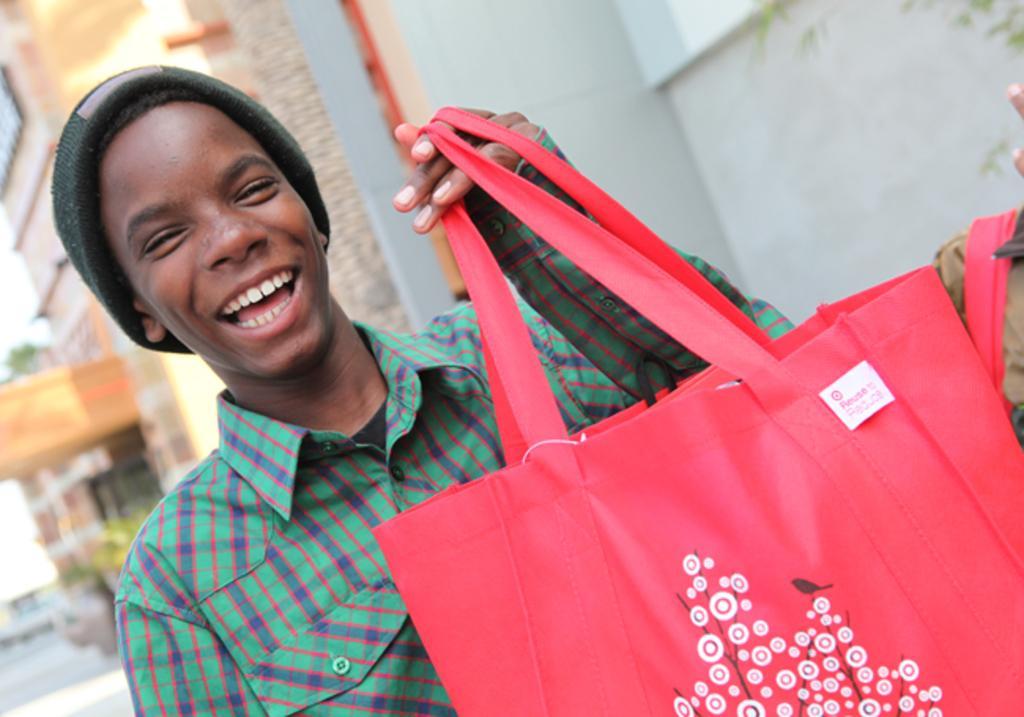Can you describe this image briefly? There is a man with a green shirt and a green cap, he is holding a red bag and he is smiling. In the background there is a building. 